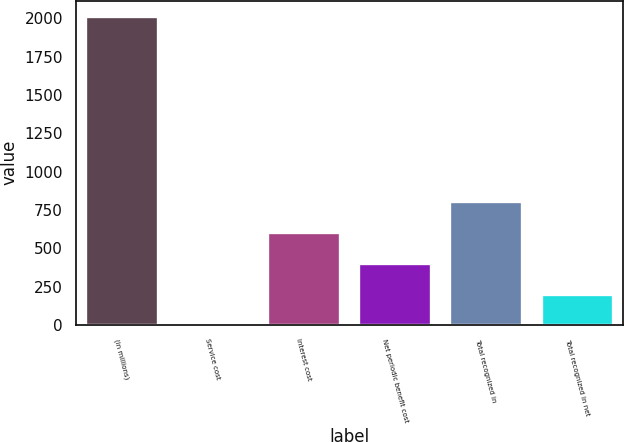Convert chart to OTSL. <chart><loc_0><loc_0><loc_500><loc_500><bar_chart><fcel>(in millions)<fcel>Service cost<fcel>Interest cost<fcel>Net periodic benefit cost<fcel>Total recognized in<fcel>Total recognized in net<nl><fcel>2016<fcel>2<fcel>606.2<fcel>404.8<fcel>807.6<fcel>203.4<nl></chart> 